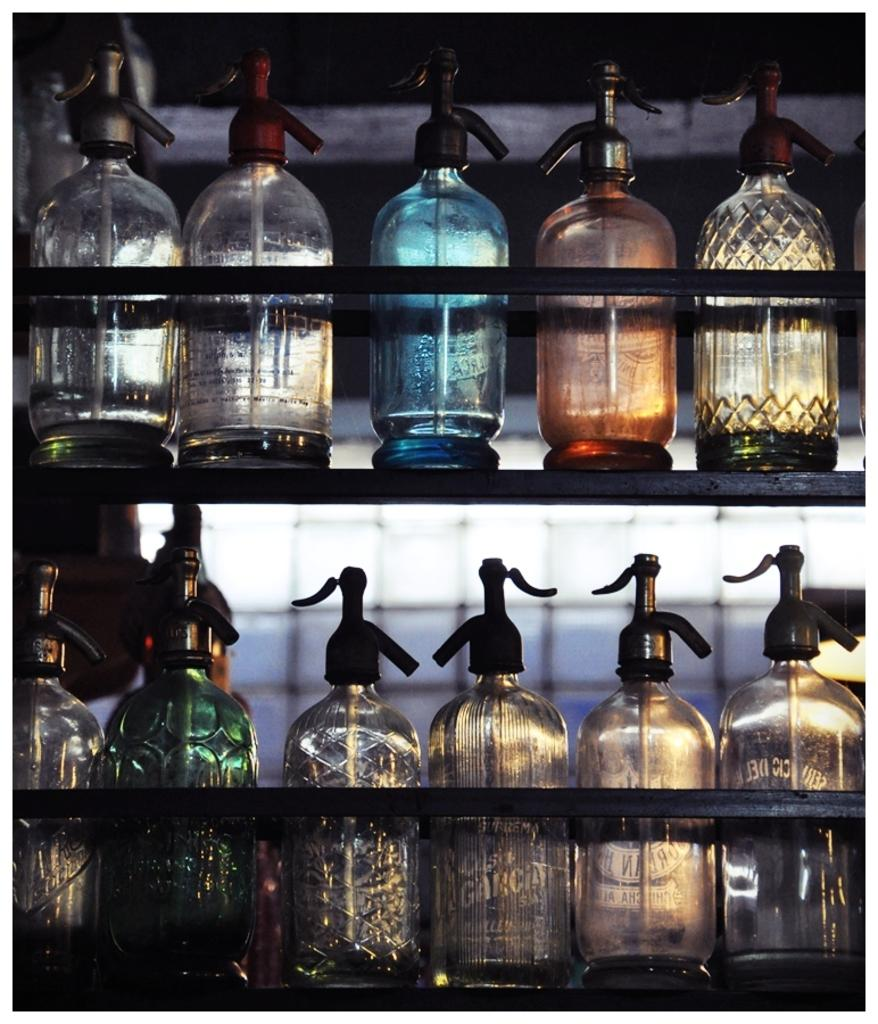What objects are in the rack in the image? There are bottles in the rack in the image. How many cows are present in the image? There are no cows present in the image; it only features a rack with bottles. 